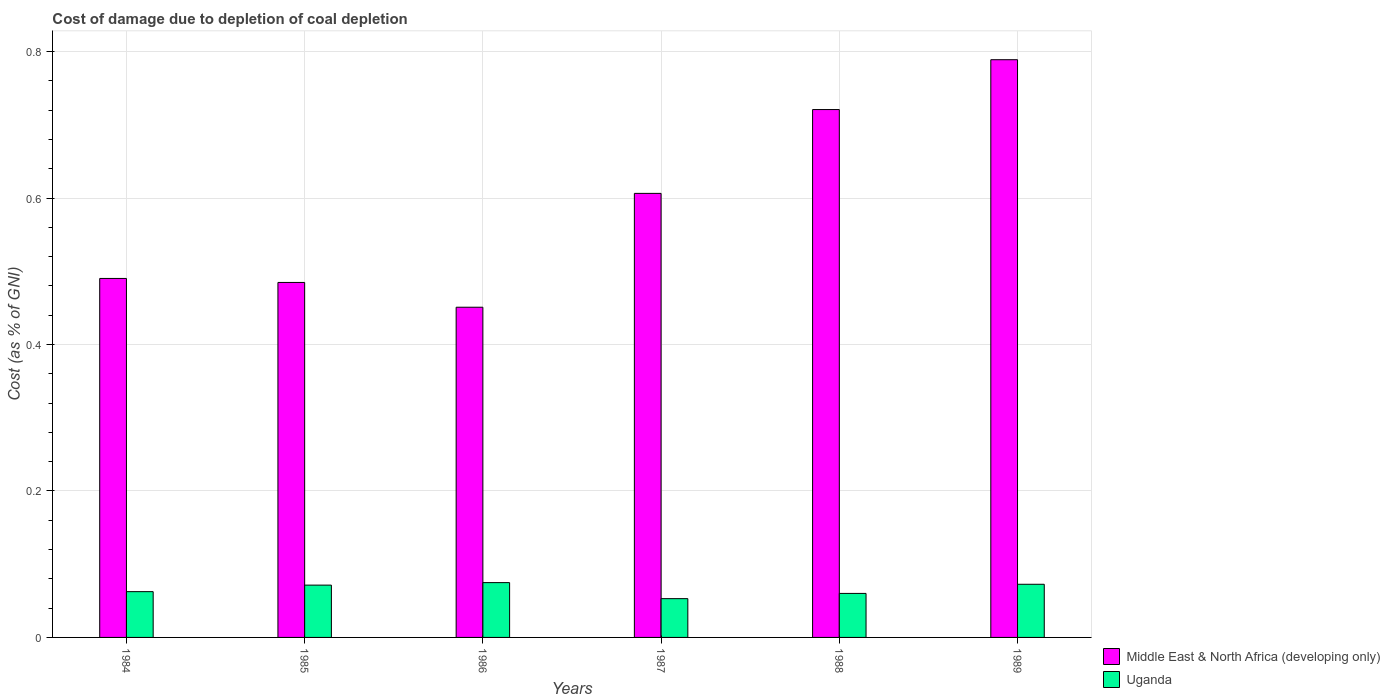How many groups of bars are there?
Keep it short and to the point. 6. How many bars are there on the 2nd tick from the left?
Provide a short and direct response. 2. How many bars are there on the 5th tick from the right?
Offer a very short reply. 2. What is the label of the 1st group of bars from the left?
Your answer should be compact. 1984. What is the cost of damage caused due to coal depletion in Uganda in 1986?
Keep it short and to the point. 0.07. Across all years, what is the maximum cost of damage caused due to coal depletion in Middle East & North Africa (developing only)?
Offer a very short reply. 0.79. Across all years, what is the minimum cost of damage caused due to coal depletion in Uganda?
Provide a short and direct response. 0.05. What is the total cost of damage caused due to coal depletion in Middle East & North Africa (developing only) in the graph?
Your answer should be very brief. 3.54. What is the difference between the cost of damage caused due to coal depletion in Uganda in 1984 and that in 1985?
Make the answer very short. -0.01. What is the difference between the cost of damage caused due to coal depletion in Uganda in 1987 and the cost of damage caused due to coal depletion in Middle East & North Africa (developing only) in 1984?
Your answer should be compact. -0.44. What is the average cost of damage caused due to coal depletion in Uganda per year?
Provide a succinct answer. 0.07. In the year 1986, what is the difference between the cost of damage caused due to coal depletion in Uganda and cost of damage caused due to coal depletion in Middle East & North Africa (developing only)?
Provide a succinct answer. -0.38. In how many years, is the cost of damage caused due to coal depletion in Uganda greater than 0.28 %?
Keep it short and to the point. 0. What is the ratio of the cost of damage caused due to coal depletion in Uganda in 1986 to that in 1989?
Your answer should be very brief. 1.03. Is the cost of damage caused due to coal depletion in Uganda in 1988 less than that in 1989?
Your response must be concise. Yes. Is the difference between the cost of damage caused due to coal depletion in Uganda in 1986 and 1989 greater than the difference between the cost of damage caused due to coal depletion in Middle East & North Africa (developing only) in 1986 and 1989?
Ensure brevity in your answer.  Yes. What is the difference between the highest and the second highest cost of damage caused due to coal depletion in Uganda?
Offer a very short reply. 0. What is the difference between the highest and the lowest cost of damage caused due to coal depletion in Uganda?
Offer a very short reply. 0.02. In how many years, is the cost of damage caused due to coal depletion in Uganda greater than the average cost of damage caused due to coal depletion in Uganda taken over all years?
Give a very brief answer. 3. Is the sum of the cost of damage caused due to coal depletion in Middle East & North Africa (developing only) in 1984 and 1986 greater than the maximum cost of damage caused due to coal depletion in Uganda across all years?
Provide a succinct answer. Yes. What does the 1st bar from the left in 1985 represents?
Provide a short and direct response. Middle East & North Africa (developing only). What does the 2nd bar from the right in 1987 represents?
Offer a terse response. Middle East & North Africa (developing only). How many bars are there?
Your answer should be very brief. 12. Are all the bars in the graph horizontal?
Provide a short and direct response. No. How many years are there in the graph?
Ensure brevity in your answer.  6. Does the graph contain any zero values?
Provide a short and direct response. No. What is the title of the graph?
Provide a succinct answer. Cost of damage due to depletion of coal depletion. Does "Venezuela" appear as one of the legend labels in the graph?
Offer a very short reply. No. What is the label or title of the X-axis?
Offer a very short reply. Years. What is the label or title of the Y-axis?
Your response must be concise. Cost (as % of GNI). What is the Cost (as % of GNI) in Middle East & North Africa (developing only) in 1984?
Ensure brevity in your answer.  0.49. What is the Cost (as % of GNI) in Uganda in 1984?
Keep it short and to the point. 0.06. What is the Cost (as % of GNI) in Middle East & North Africa (developing only) in 1985?
Keep it short and to the point. 0.48. What is the Cost (as % of GNI) of Uganda in 1985?
Offer a terse response. 0.07. What is the Cost (as % of GNI) of Middle East & North Africa (developing only) in 1986?
Keep it short and to the point. 0.45. What is the Cost (as % of GNI) of Uganda in 1986?
Offer a terse response. 0.07. What is the Cost (as % of GNI) of Middle East & North Africa (developing only) in 1987?
Ensure brevity in your answer.  0.61. What is the Cost (as % of GNI) in Uganda in 1987?
Keep it short and to the point. 0.05. What is the Cost (as % of GNI) in Middle East & North Africa (developing only) in 1988?
Offer a very short reply. 0.72. What is the Cost (as % of GNI) in Uganda in 1988?
Ensure brevity in your answer.  0.06. What is the Cost (as % of GNI) of Middle East & North Africa (developing only) in 1989?
Your answer should be compact. 0.79. What is the Cost (as % of GNI) of Uganda in 1989?
Provide a short and direct response. 0.07. Across all years, what is the maximum Cost (as % of GNI) in Middle East & North Africa (developing only)?
Ensure brevity in your answer.  0.79. Across all years, what is the maximum Cost (as % of GNI) of Uganda?
Make the answer very short. 0.07. Across all years, what is the minimum Cost (as % of GNI) in Middle East & North Africa (developing only)?
Give a very brief answer. 0.45. Across all years, what is the minimum Cost (as % of GNI) in Uganda?
Your answer should be compact. 0.05. What is the total Cost (as % of GNI) of Middle East & North Africa (developing only) in the graph?
Keep it short and to the point. 3.54. What is the total Cost (as % of GNI) of Uganda in the graph?
Provide a succinct answer. 0.39. What is the difference between the Cost (as % of GNI) in Middle East & North Africa (developing only) in 1984 and that in 1985?
Ensure brevity in your answer.  0.01. What is the difference between the Cost (as % of GNI) in Uganda in 1984 and that in 1985?
Keep it short and to the point. -0.01. What is the difference between the Cost (as % of GNI) of Middle East & North Africa (developing only) in 1984 and that in 1986?
Your answer should be compact. 0.04. What is the difference between the Cost (as % of GNI) of Uganda in 1984 and that in 1986?
Provide a succinct answer. -0.01. What is the difference between the Cost (as % of GNI) of Middle East & North Africa (developing only) in 1984 and that in 1987?
Offer a very short reply. -0.12. What is the difference between the Cost (as % of GNI) in Uganda in 1984 and that in 1987?
Give a very brief answer. 0.01. What is the difference between the Cost (as % of GNI) of Middle East & North Africa (developing only) in 1984 and that in 1988?
Give a very brief answer. -0.23. What is the difference between the Cost (as % of GNI) in Uganda in 1984 and that in 1988?
Your answer should be very brief. 0. What is the difference between the Cost (as % of GNI) in Middle East & North Africa (developing only) in 1984 and that in 1989?
Your response must be concise. -0.3. What is the difference between the Cost (as % of GNI) in Uganda in 1984 and that in 1989?
Make the answer very short. -0.01. What is the difference between the Cost (as % of GNI) of Middle East & North Africa (developing only) in 1985 and that in 1986?
Offer a terse response. 0.03. What is the difference between the Cost (as % of GNI) of Uganda in 1985 and that in 1986?
Offer a terse response. -0. What is the difference between the Cost (as % of GNI) in Middle East & North Africa (developing only) in 1985 and that in 1987?
Offer a very short reply. -0.12. What is the difference between the Cost (as % of GNI) in Uganda in 1985 and that in 1987?
Ensure brevity in your answer.  0.02. What is the difference between the Cost (as % of GNI) in Middle East & North Africa (developing only) in 1985 and that in 1988?
Keep it short and to the point. -0.24. What is the difference between the Cost (as % of GNI) in Uganda in 1985 and that in 1988?
Your answer should be very brief. 0.01. What is the difference between the Cost (as % of GNI) in Middle East & North Africa (developing only) in 1985 and that in 1989?
Make the answer very short. -0.3. What is the difference between the Cost (as % of GNI) of Uganda in 1985 and that in 1989?
Your answer should be compact. -0. What is the difference between the Cost (as % of GNI) in Middle East & North Africa (developing only) in 1986 and that in 1987?
Provide a short and direct response. -0.16. What is the difference between the Cost (as % of GNI) of Uganda in 1986 and that in 1987?
Provide a succinct answer. 0.02. What is the difference between the Cost (as % of GNI) of Middle East & North Africa (developing only) in 1986 and that in 1988?
Provide a succinct answer. -0.27. What is the difference between the Cost (as % of GNI) in Uganda in 1986 and that in 1988?
Offer a terse response. 0.01. What is the difference between the Cost (as % of GNI) in Middle East & North Africa (developing only) in 1986 and that in 1989?
Give a very brief answer. -0.34. What is the difference between the Cost (as % of GNI) of Uganda in 1986 and that in 1989?
Provide a short and direct response. 0. What is the difference between the Cost (as % of GNI) of Middle East & North Africa (developing only) in 1987 and that in 1988?
Provide a succinct answer. -0.11. What is the difference between the Cost (as % of GNI) of Uganda in 1987 and that in 1988?
Your answer should be compact. -0.01. What is the difference between the Cost (as % of GNI) in Middle East & North Africa (developing only) in 1987 and that in 1989?
Ensure brevity in your answer.  -0.18. What is the difference between the Cost (as % of GNI) in Uganda in 1987 and that in 1989?
Provide a succinct answer. -0.02. What is the difference between the Cost (as % of GNI) of Middle East & North Africa (developing only) in 1988 and that in 1989?
Provide a short and direct response. -0.07. What is the difference between the Cost (as % of GNI) of Uganda in 1988 and that in 1989?
Keep it short and to the point. -0.01. What is the difference between the Cost (as % of GNI) in Middle East & North Africa (developing only) in 1984 and the Cost (as % of GNI) in Uganda in 1985?
Offer a terse response. 0.42. What is the difference between the Cost (as % of GNI) in Middle East & North Africa (developing only) in 1984 and the Cost (as % of GNI) in Uganda in 1986?
Your response must be concise. 0.42. What is the difference between the Cost (as % of GNI) of Middle East & North Africa (developing only) in 1984 and the Cost (as % of GNI) of Uganda in 1987?
Provide a short and direct response. 0.44. What is the difference between the Cost (as % of GNI) in Middle East & North Africa (developing only) in 1984 and the Cost (as % of GNI) in Uganda in 1988?
Offer a terse response. 0.43. What is the difference between the Cost (as % of GNI) in Middle East & North Africa (developing only) in 1984 and the Cost (as % of GNI) in Uganda in 1989?
Provide a succinct answer. 0.42. What is the difference between the Cost (as % of GNI) of Middle East & North Africa (developing only) in 1985 and the Cost (as % of GNI) of Uganda in 1986?
Provide a short and direct response. 0.41. What is the difference between the Cost (as % of GNI) in Middle East & North Africa (developing only) in 1985 and the Cost (as % of GNI) in Uganda in 1987?
Provide a succinct answer. 0.43. What is the difference between the Cost (as % of GNI) in Middle East & North Africa (developing only) in 1985 and the Cost (as % of GNI) in Uganda in 1988?
Keep it short and to the point. 0.42. What is the difference between the Cost (as % of GNI) of Middle East & North Africa (developing only) in 1985 and the Cost (as % of GNI) of Uganda in 1989?
Provide a short and direct response. 0.41. What is the difference between the Cost (as % of GNI) in Middle East & North Africa (developing only) in 1986 and the Cost (as % of GNI) in Uganda in 1987?
Your answer should be compact. 0.4. What is the difference between the Cost (as % of GNI) in Middle East & North Africa (developing only) in 1986 and the Cost (as % of GNI) in Uganda in 1988?
Your answer should be compact. 0.39. What is the difference between the Cost (as % of GNI) in Middle East & North Africa (developing only) in 1986 and the Cost (as % of GNI) in Uganda in 1989?
Offer a terse response. 0.38. What is the difference between the Cost (as % of GNI) of Middle East & North Africa (developing only) in 1987 and the Cost (as % of GNI) of Uganda in 1988?
Make the answer very short. 0.55. What is the difference between the Cost (as % of GNI) of Middle East & North Africa (developing only) in 1987 and the Cost (as % of GNI) of Uganda in 1989?
Keep it short and to the point. 0.53. What is the difference between the Cost (as % of GNI) of Middle East & North Africa (developing only) in 1988 and the Cost (as % of GNI) of Uganda in 1989?
Offer a very short reply. 0.65. What is the average Cost (as % of GNI) in Middle East & North Africa (developing only) per year?
Keep it short and to the point. 0.59. What is the average Cost (as % of GNI) of Uganda per year?
Make the answer very short. 0.07. In the year 1984, what is the difference between the Cost (as % of GNI) of Middle East & North Africa (developing only) and Cost (as % of GNI) of Uganda?
Provide a short and direct response. 0.43. In the year 1985, what is the difference between the Cost (as % of GNI) of Middle East & North Africa (developing only) and Cost (as % of GNI) of Uganda?
Provide a succinct answer. 0.41. In the year 1986, what is the difference between the Cost (as % of GNI) of Middle East & North Africa (developing only) and Cost (as % of GNI) of Uganda?
Make the answer very short. 0.38. In the year 1987, what is the difference between the Cost (as % of GNI) in Middle East & North Africa (developing only) and Cost (as % of GNI) in Uganda?
Ensure brevity in your answer.  0.55. In the year 1988, what is the difference between the Cost (as % of GNI) of Middle East & North Africa (developing only) and Cost (as % of GNI) of Uganda?
Provide a succinct answer. 0.66. In the year 1989, what is the difference between the Cost (as % of GNI) in Middle East & North Africa (developing only) and Cost (as % of GNI) in Uganda?
Ensure brevity in your answer.  0.72. What is the ratio of the Cost (as % of GNI) in Middle East & North Africa (developing only) in 1984 to that in 1985?
Provide a succinct answer. 1.01. What is the ratio of the Cost (as % of GNI) in Uganda in 1984 to that in 1985?
Your response must be concise. 0.88. What is the ratio of the Cost (as % of GNI) of Middle East & North Africa (developing only) in 1984 to that in 1986?
Your answer should be compact. 1.09. What is the ratio of the Cost (as % of GNI) in Uganda in 1984 to that in 1986?
Make the answer very short. 0.84. What is the ratio of the Cost (as % of GNI) in Middle East & North Africa (developing only) in 1984 to that in 1987?
Offer a terse response. 0.81. What is the ratio of the Cost (as % of GNI) of Uganda in 1984 to that in 1987?
Offer a terse response. 1.18. What is the ratio of the Cost (as % of GNI) of Middle East & North Africa (developing only) in 1984 to that in 1988?
Your answer should be compact. 0.68. What is the ratio of the Cost (as % of GNI) in Uganda in 1984 to that in 1988?
Provide a short and direct response. 1.04. What is the ratio of the Cost (as % of GNI) in Middle East & North Africa (developing only) in 1984 to that in 1989?
Give a very brief answer. 0.62. What is the ratio of the Cost (as % of GNI) of Uganda in 1984 to that in 1989?
Offer a terse response. 0.86. What is the ratio of the Cost (as % of GNI) of Middle East & North Africa (developing only) in 1985 to that in 1986?
Your answer should be compact. 1.07. What is the ratio of the Cost (as % of GNI) of Uganda in 1985 to that in 1986?
Provide a succinct answer. 0.95. What is the ratio of the Cost (as % of GNI) in Middle East & North Africa (developing only) in 1985 to that in 1987?
Make the answer very short. 0.8. What is the ratio of the Cost (as % of GNI) of Uganda in 1985 to that in 1987?
Offer a very short reply. 1.35. What is the ratio of the Cost (as % of GNI) in Middle East & North Africa (developing only) in 1985 to that in 1988?
Give a very brief answer. 0.67. What is the ratio of the Cost (as % of GNI) in Uganda in 1985 to that in 1988?
Provide a succinct answer. 1.19. What is the ratio of the Cost (as % of GNI) in Middle East & North Africa (developing only) in 1985 to that in 1989?
Keep it short and to the point. 0.61. What is the ratio of the Cost (as % of GNI) of Uganda in 1985 to that in 1989?
Your answer should be compact. 0.98. What is the ratio of the Cost (as % of GNI) in Middle East & North Africa (developing only) in 1986 to that in 1987?
Keep it short and to the point. 0.74. What is the ratio of the Cost (as % of GNI) in Uganda in 1986 to that in 1987?
Offer a very short reply. 1.41. What is the ratio of the Cost (as % of GNI) in Middle East & North Africa (developing only) in 1986 to that in 1988?
Your answer should be very brief. 0.63. What is the ratio of the Cost (as % of GNI) in Uganda in 1986 to that in 1988?
Provide a succinct answer. 1.25. What is the ratio of the Cost (as % of GNI) in Middle East & North Africa (developing only) in 1986 to that in 1989?
Your response must be concise. 0.57. What is the ratio of the Cost (as % of GNI) of Uganda in 1986 to that in 1989?
Your answer should be very brief. 1.03. What is the ratio of the Cost (as % of GNI) of Middle East & North Africa (developing only) in 1987 to that in 1988?
Offer a very short reply. 0.84. What is the ratio of the Cost (as % of GNI) in Uganda in 1987 to that in 1988?
Keep it short and to the point. 0.88. What is the ratio of the Cost (as % of GNI) in Middle East & North Africa (developing only) in 1987 to that in 1989?
Your response must be concise. 0.77. What is the ratio of the Cost (as % of GNI) of Uganda in 1987 to that in 1989?
Your answer should be very brief. 0.73. What is the ratio of the Cost (as % of GNI) in Middle East & North Africa (developing only) in 1988 to that in 1989?
Keep it short and to the point. 0.91. What is the ratio of the Cost (as % of GNI) of Uganda in 1988 to that in 1989?
Your answer should be compact. 0.83. What is the difference between the highest and the second highest Cost (as % of GNI) in Middle East & North Africa (developing only)?
Provide a short and direct response. 0.07. What is the difference between the highest and the second highest Cost (as % of GNI) of Uganda?
Your response must be concise. 0. What is the difference between the highest and the lowest Cost (as % of GNI) of Middle East & North Africa (developing only)?
Offer a terse response. 0.34. What is the difference between the highest and the lowest Cost (as % of GNI) in Uganda?
Your answer should be very brief. 0.02. 